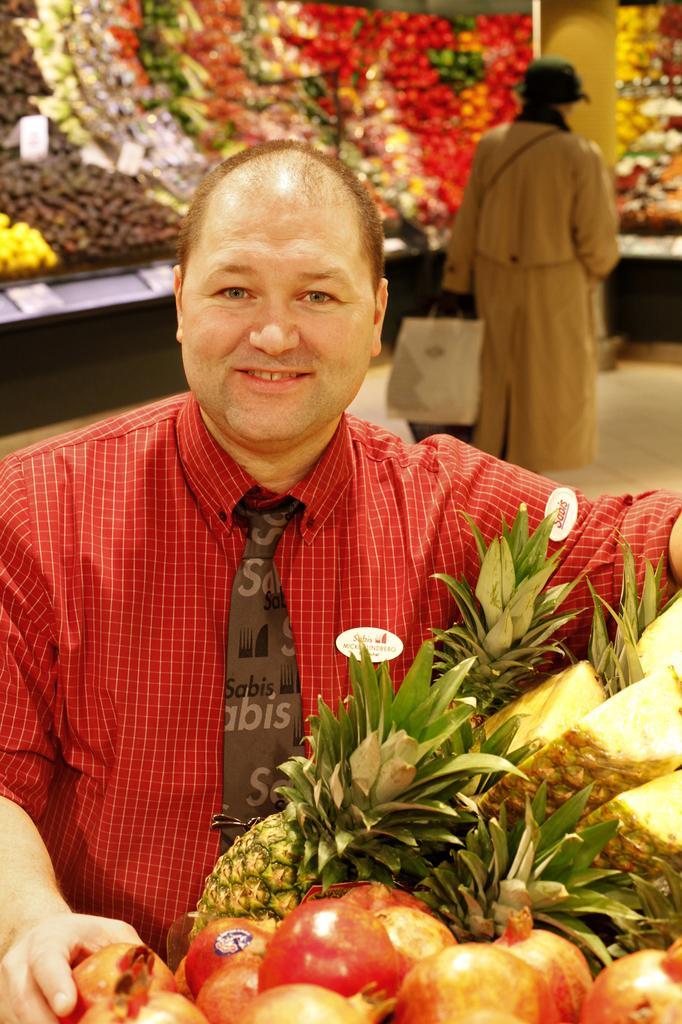Could you give a brief overview of what you see in this image? In this image I can see a person standing and wearing red color shirt. I can see different fruits around. Back I can see person holding bag. 